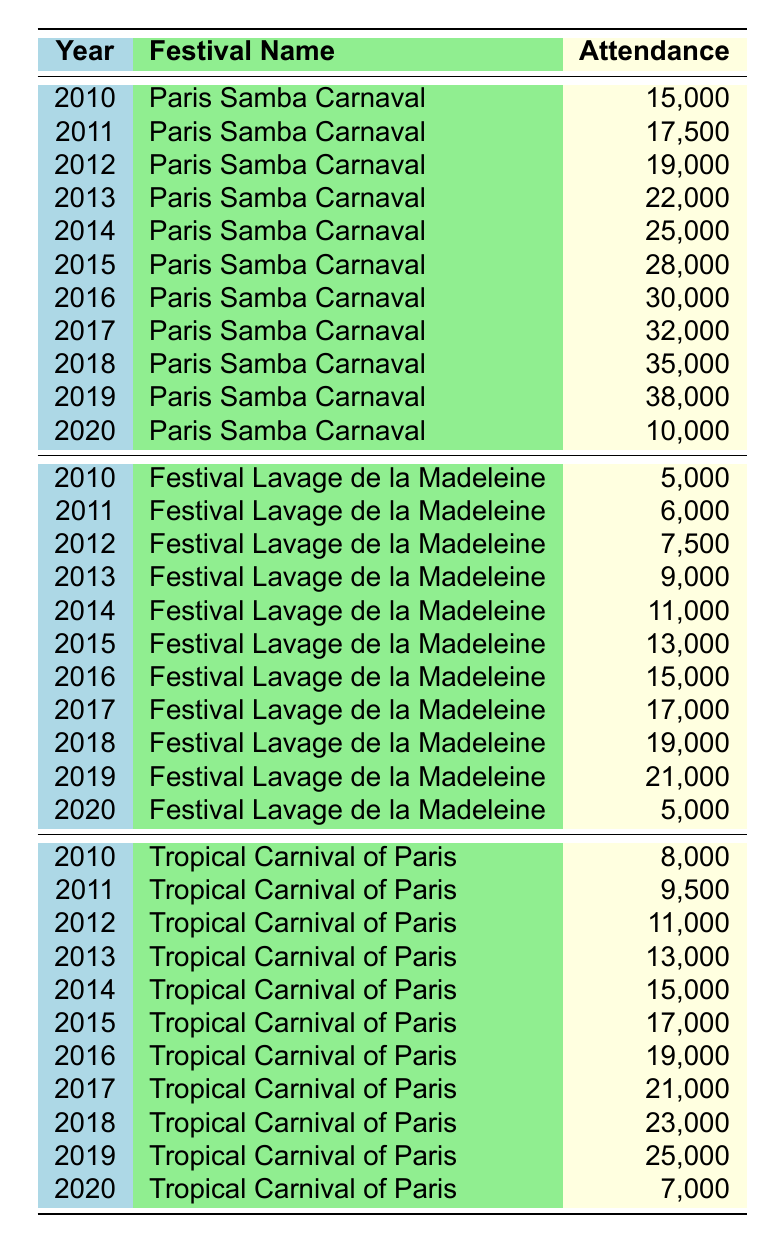What was the highest attendance at the Paris Samba Carnaval between 2010 and 2020? The highest attendance for the Paris Samba Carnaval was in 2019 with 38,000 participants.
Answer: 38,000 What was the attendance at the Festival Lavage de la Madeleine in 2015? The attendance at the Festival Lavage de la Madeleine in 2015 was 13,000.
Answer: 13,000 Which festival had the lowest attendance in 2020? In 2020, the Festival Lavage de la Madeleine had the lowest attendance with 5,000 participants.
Answer: Festival Lavage de la Madeleine What is the total attendance for the Tropical Carnival of Paris during the years 2010 to 2020? The total attendance for the Tropical Carnival of Paris from 2010 to 2020 is calculated by adding each year's attendance: 8,000 + 9,500 + 11,000 + 13,000 + 15,000 + 17,000 + 19,000 + 21,000 + 23,000 + 25,000 + 7,000 =  8,000 + 9,500 = 17,500; 17,500 + 11,000 = 28,500; 28,500 + 13,000 = 41,500; 41,500 + 15,000 = 56,500; 56,500 + 17,000 = 73,500; 73,500 + 19,000 = 92,500; 92,500 + 21,000 = 113,500; 113,500 + 23,000 = 136,500; 136,500 + 25,000 = 161,500; 161,500 + 7,000 = 168,500
Answer: 168,500 What was the attendance trend for the Paris Samba Carnaval from 2010 to 2019? The attendance trend for the Paris Samba Carnaval shows a steady increase year by year from 2010 (15,000) to 2019 (38,000), with the only significant drop in 2020 (to 10,000).
Answer: Steady increase until 2019, then a drop in 2020 Is the attendance for the Festival Lavage de la Madeleine higher than the Tropical Carnival of Paris in 2019? In 2019, the Festival Lavage de la Madeleine had an attendance of 21,000, while the Tropical Carnival of Paris had 25,000. Therefore, the attendance for the Festival Lavage de la Madeleine was not higher.
Answer: No What is the average attendance for all festivals in 2018? For 2018, the attendance figures are: Paris Samba Carnaval (35,000), Festival Lavage de la Madeleine (19,000), and Tropical Carnival of Paris (23,000). The total attendance is 35,000 + 19,000 + 23,000 = 77,000. There are 3 festivals, so the average is 77,000 / 3 = approximately 25,667.
Answer: 25,667 What was the change in attendance for the Paris Samba Carnaval from 2016 to 2020? The attendance for the Paris Samba Carnaval in 2016 was 30,000 and in 2020 it was 10,000. The change is 10,000 - 30,000 = -20,000, which indicates a decline of 20,000 attendees.
Answer: Decrease of 20,000 Which year had the highest attendance for the Festival Lavage de la Madeleine? The highest attendance for the Festival Lavage de la Madeleine was in 2019 with 21,000 attendees.
Answer: 21,000 What were the overall attendance figures for the year 2014 across all festivals? In 2014, the attendance figures are as follows: Paris Samba Carnaval (25,000), Festival Lavage de la Madeleine (11,000), and Tropical Carnival of Paris (15,000). The total is 25,000 + 11,000 + 15,000 = 51,000.
Answer: 51,000 Did more people attend the Tropical Carnival of Paris than the Paris Samba Carnaval in 2013? In 2013, the attendance for the Tropical Carnival of Paris was 13,000, while for the Paris Samba Carnaval it was 22,000. This means more people attended the Paris Samba Carnaval.
Answer: No 